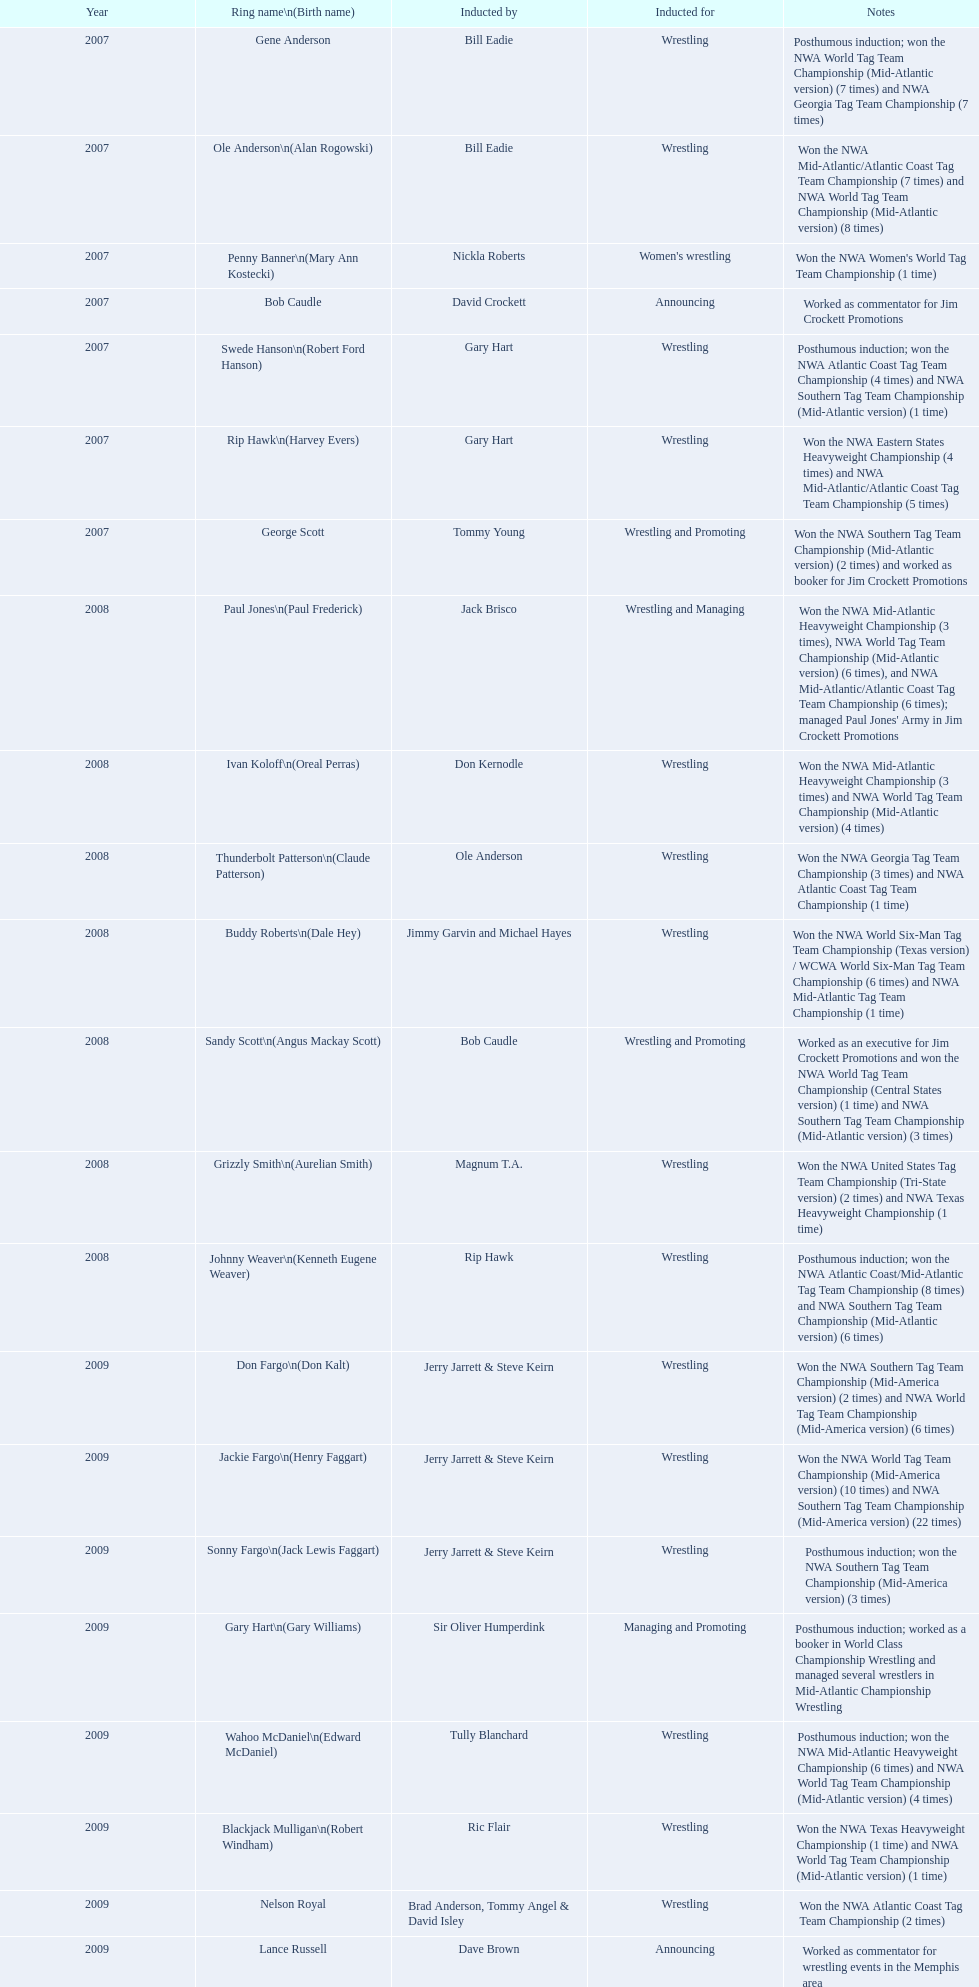What commentators were inducted? Bob Caudle, Lance Russell. What commentator was inducted in 2009? Lance Russell. 